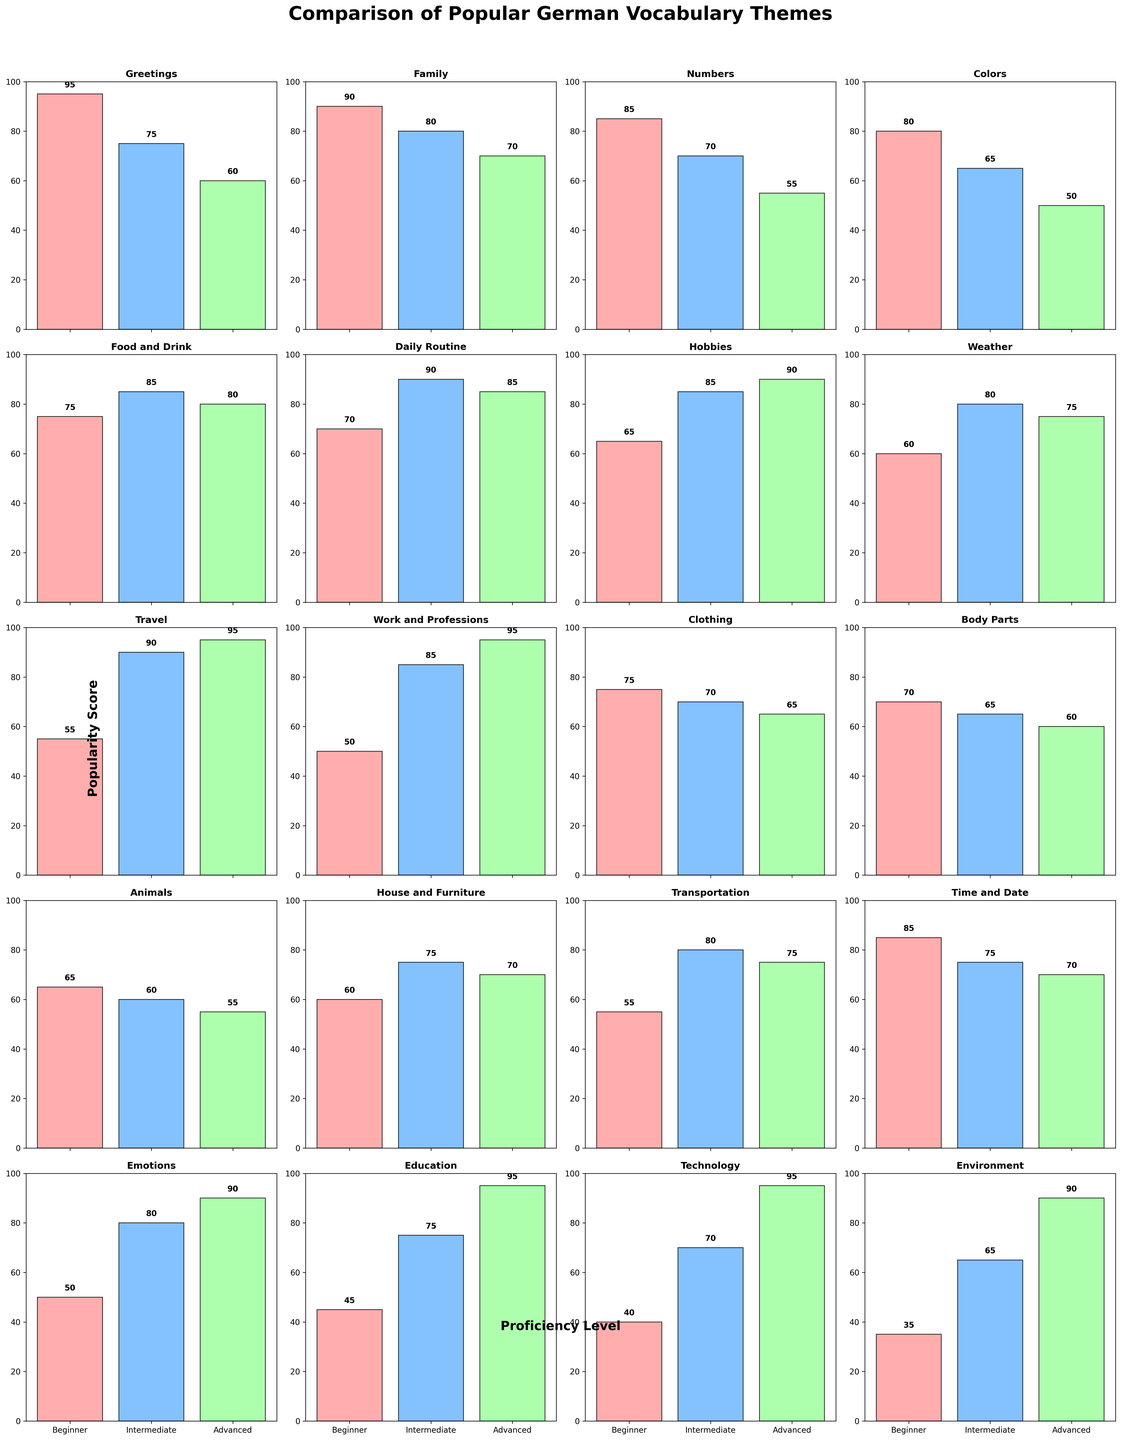Which proficiency level has the highest popularity score in the "Travel" theme? To find this, look at the "Travel" subplot and compare the bar heights for Beginner, Intermediate, and Advanced levels. The tallest bar indicates the highest score.
Answer: Advanced Which theme has the highest popularity score for the Beginner level? Examine the bar heights for all themes at the Beginner level. The theme with the tallest bar has the highest score.
Answer: Greetings What is the combined popularity score for the Intermediate and Advanced levels in the "Emotions" theme? Add the values for Intermediate and Advanced in the "Emotions" subplot: Intermediate (80) + Advanced (90).
Answer: 170 Which proficiency level has the lowest popularity score in the "Technology" theme? Look at the "Technology" subplot, and assess the bar heights for Beginner, Intermediate, and Advanced levels. The shortest bar represents the lowest score.
Answer: Beginner Compare the popularity scores of "Daily Routine" and "Weather" at the Intermediate level. Which theme is more popular? Look at the bar heights for "Daily Routine" and "Weather" at the Intermediate level. The taller bar represents the more popular theme.
Answer: Daily Routine Among the themes "Food and Drink" and "Hobbies", which one has a higher average popularity score across all proficiency levels? Calculate the average scores for both themes. For "Food and Drink": (75+85+80)/3 ≈ 80. For "Hobbies": (65+85+90)/3 ≈ 80.
Answer: Both are equal What's the average popularity score for the Advanced level across all themes? Add all Advanced scores and divide by the number of themes. Sum = 60 + 70 + 55 + 50 + 80 + 85 + 90 + 75 + 95 + 95 + 65 + 60 + 55 + 70 + 75 + 70 + 90 + 95 + 95 + 90 = 1430. Average = 1430/20.
Answer: 71.5 In the "Work and Professions" theme, which proficiency level has approximately 1.5 times the score of the Beginner level? Check "Work and Professions" subplot. Beginner score is 50. 1.5 times 50 is 75. Look for the level with a score close to 75.
Answer: Intermediate Which two themes have the same popularity score for the Intermediate level? Compare the bars for Intermediate level across all themes. Find themes with equal bar heights.
Answer: Colors and Body Parts 